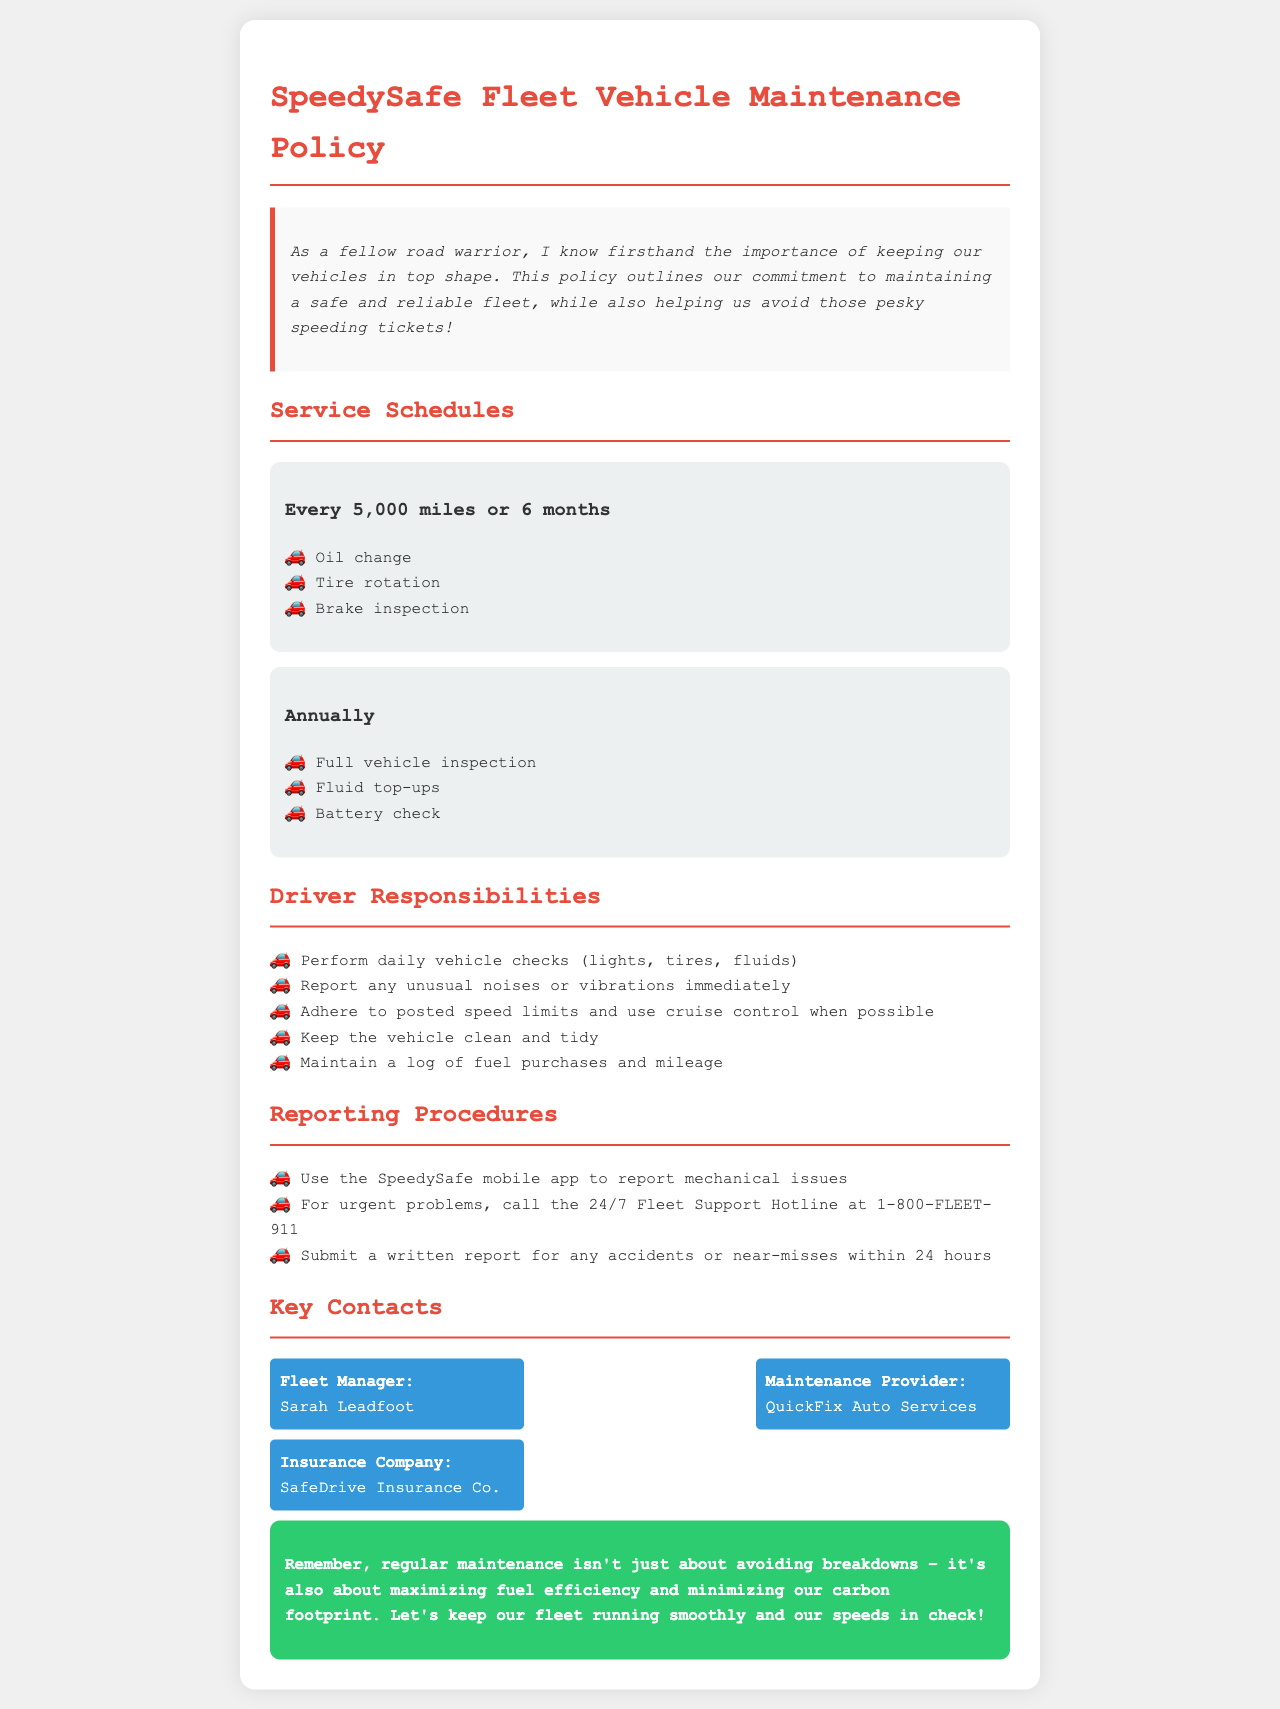what is the oil change interval? The oil change should occur every 5,000 miles or 6 months.
Answer: every 5,000 miles or 6 months who is the Fleet Manager? The document specifies that the Fleet Manager is Sarah Leadfoot.
Answer: Sarah Leadfoot what should drivers do if they notice unusual noises? Drivers should report any unusual noises or vibrations immediately.
Answer: report immediately how often is a full vehicle inspection required? A full vehicle inspection is required annually.
Answer: annually what needs to be submitted within 24 hours after an accident? A written report for any accidents or near-misses must be submitted within 24 hours.
Answer: written report what mobile tool is used for reporting mechanical issues? The SpeedySafe mobile app is used for reporting mechanical issues.
Answer: SpeedySafe mobile app how many key contacts are listed in the document? There are three key contacts listed in the document.
Answer: three which maintenance provider is mentioned? The maintenance provider mentioned in the document is QuickFix Auto Services.
Answer: QuickFix Auto Services what is a primary driver responsibility? A primary responsibility is to perform daily vehicle checks.
Answer: perform daily vehicle checks 